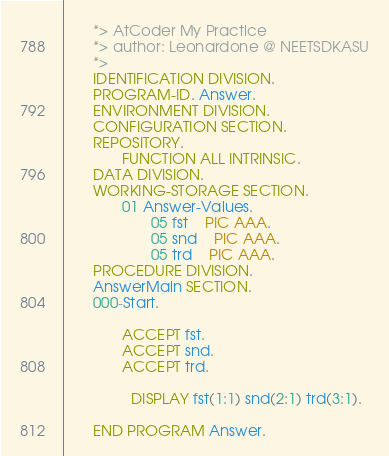<code> <loc_0><loc_0><loc_500><loc_500><_COBOL_>       *> AtCoder My Practice
       *> author: Leonardone @ NEETSDKASU
       *>
       IDENTIFICATION DIVISION.
       PROGRAM-ID. Answer.
       ENVIRONMENT DIVISION.
       CONFIGURATION SECTION.
       REPOSITORY.
              FUNCTION ALL INTRINSIC.
       DATA DIVISION.
       WORKING-STORAGE SECTION.
              01 Answer-Values.
                     05 fst    PIC AAA.
                     05 snd    PIC AAA.
                     05 trd    PIC AAA.
       PROCEDURE DIVISION.
       AnswerMain SECTION.
       000-Start.
       
              ACCEPT fst.
              ACCEPT snd.
              ACCEPT trd.
      
      	      DISPLAY fst(1:1) snd(2:1) trd(3:1).
              
       END PROGRAM Answer.
</code> 